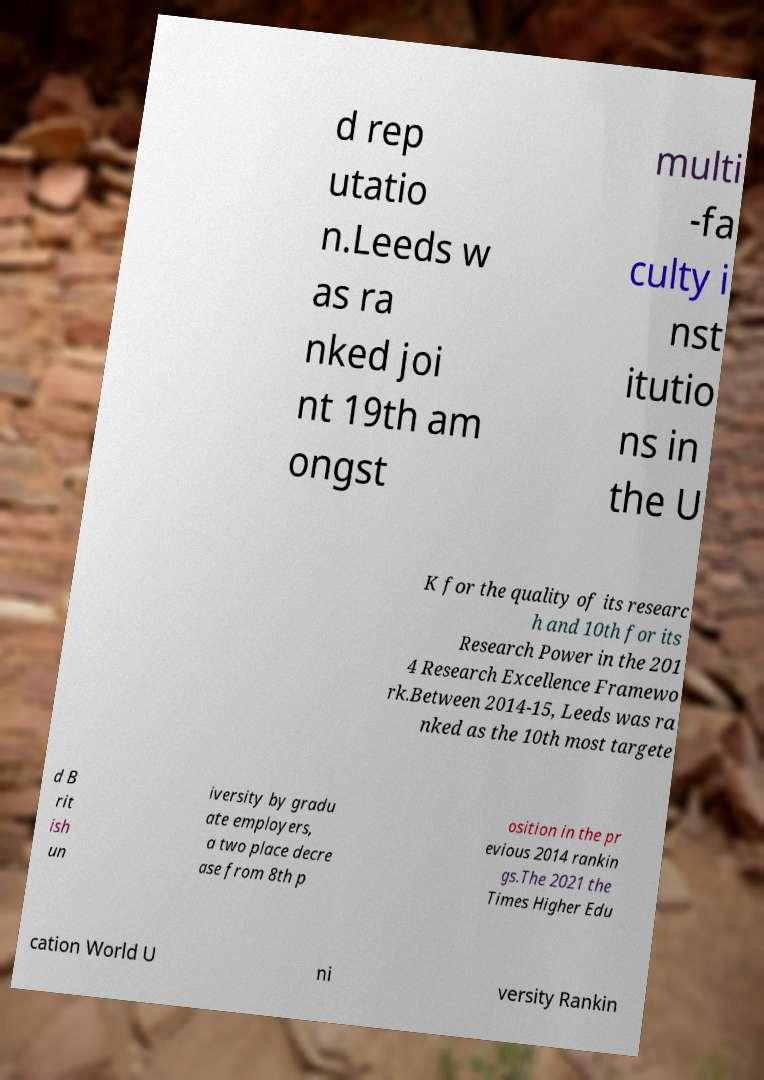There's text embedded in this image that I need extracted. Can you transcribe it verbatim? d rep utatio n.Leeds w as ra nked joi nt 19th am ongst multi -fa culty i nst itutio ns in the U K for the quality of its researc h and 10th for its Research Power in the 201 4 Research Excellence Framewo rk.Between 2014-15, Leeds was ra nked as the 10th most targete d B rit ish un iversity by gradu ate employers, a two place decre ase from 8th p osition in the pr evious 2014 rankin gs.The 2021 the Times Higher Edu cation World U ni versity Rankin 